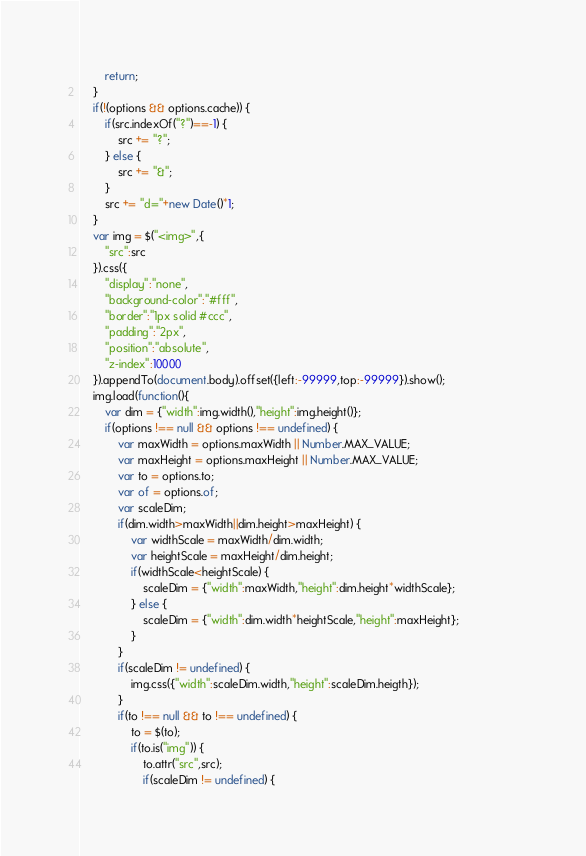<code> <loc_0><loc_0><loc_500><loc_500><_JavaScript_>		return;
	}
	if(!(options && options.cache)) {
		if(src.indexOf("?")==-1) {
			src += "?";
		} else {
			src += "&";
		}
		src += "d="+new Date()*1;		
	}
	var img = $("<img>",{
		"src":src
	}).css({
		"display":"none",
		"background-color":"#fff",
		"border":"1px solid #ccc",
		"padding":"2px",
		"position":"absolute",
		"z-index":10000
	}).appendTo(document.body).offset({left:-99999,top:-99999}).show();
	img.load(function(){
		var dim = {"width":img.width(),"height":img.height()};
		if(options !== null && options !== undefined) {
			var maxWidth = options.maxWidth || Number.MAX_VALUE;
			var maxHeight = options.maxHeight || Number.MAX_VALUE;
			var to = options.to;
			var of = options.of;
			var scaleDim;
			if(dim.width>maxWidth||dim.height>maxHeight) {
				var widthScale = maxWidth/dim.width;
				var heightScale = maxHeight/dim.height;
				if(widthScale<heightScale) {
					scaleDim = {"width":maxWidth,"height":dim.height*widthScale};					
				} else {
					scaleDim = {"width":dim.width*heightScale,"height":maxHeight};
				}
			}
			if(scaleDim != undefined) {
				img.css({"width":scaleDim.width,"height":scaleDim.heigth});
			}
			if(to !== null && to !== undefined) {
				to = $(to);
				if(to.is("img")) {
					to.attr("src",src);
					if(scaleDim != undefined) {</code> 